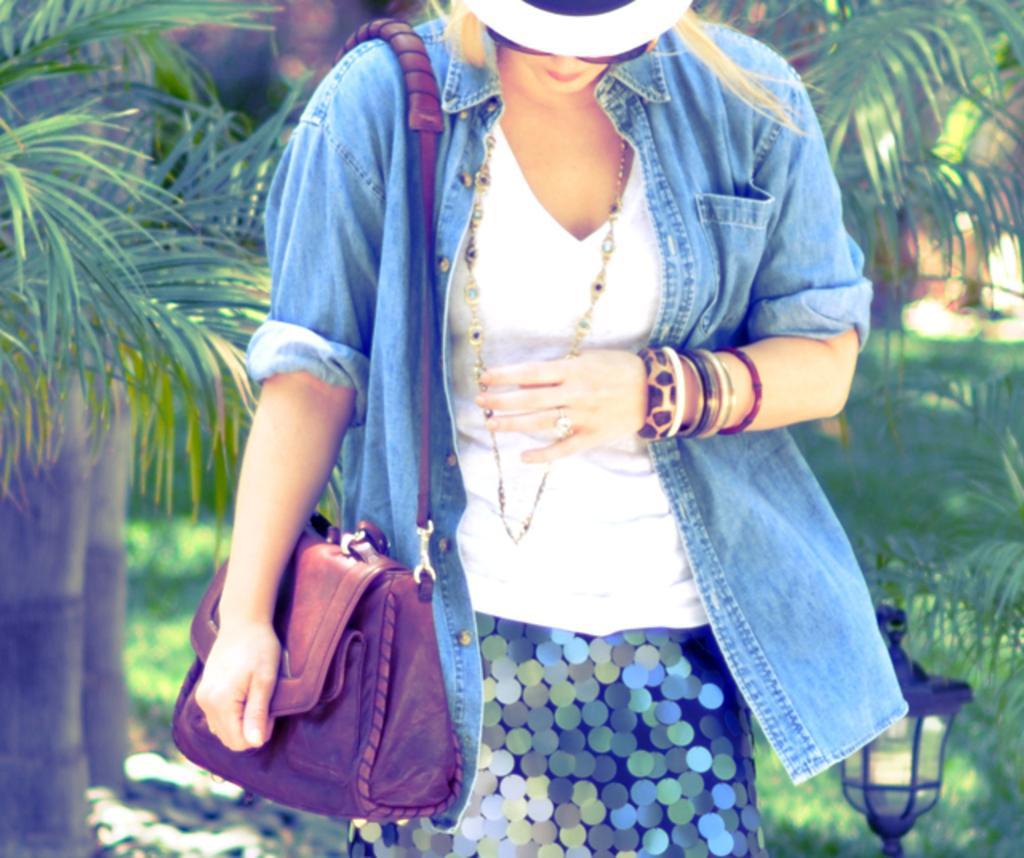Describe this image in one or two sentences. The woman is highlighted in this picture. She wore blue jacket, white t-shirt, bangles, chain and skirt. She is carrying brown bag. Far there are trees in green color. Grass is in green color. The lantern lamp. The woman looking downwards. 